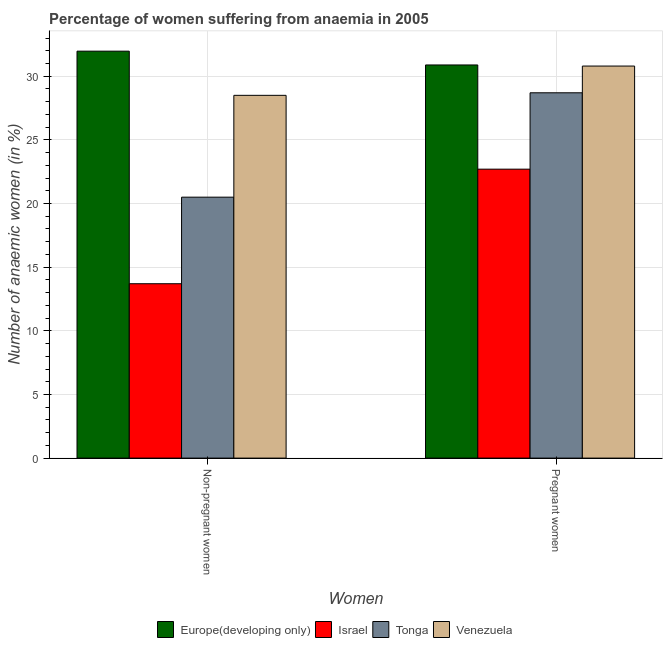How many different coloured bars are there?
Give a very brief answer. 4. How many bars are there on the 2nd tick from the left?
Your response must be concise. 4. What is the label of the 1st group of bars from the left?
Offer a very short reply. Non-pregnant women. What is the percentage of pregnant anaemic women in Venezuela?
Offer a very short reply. 30.8. Across all countries, what is the maximum percentage of pregnant anaemic women?
Give a very brief answer. 30.89. In which country was the percentage of pregnant anaemic women maximum?
Your answer should be compact. Europe(developing only). What is the total percentage of pregnant anaemic women in the graph?
Your answer should be very brief. 113.09. What is the difference between the percentage of non-pregnant anaemic women in Tonga and that in Venezuela?
Make the answer very short. -8. What is the difference between the percentage of pregnant anaemic women in Europe(developing only) and the percentage of non-pregnant anaemic women in Israel?
Your answer should be compact. 17.19. What is the average percentage of non-pregnant anaemic women per country?
Your answer should be compact. 23.67. What is the difference between the percentage of pregnant anaemic women and percentage of non-pregnant anaemic women in Europe(developing only)?
Give a very brief answer. -1.08. In how many countries, is the percentage of pregnant anaemic women greater than 26 %?
Keep it short and to the point. 3. What is the ratio of the percentage of non-pregnant anaemic women in Israel to that in Tonga?
Provide a succinct answer. 0.67. What does the 1st bar from the left in Pregnant women represents?
Provide a short and direct response. Europe(developing only). What does the 2nd bar from the right in Non-pregnant women represents?
Ensure brevity in your answer.  Tonga. How many countries are there in the graph?
Offer a very short reply. 4. What is the difference between two consecutive major ticks on the Y-axis?
Give a very brief answer. 5. Does the graph contain grids?
Provide a short and direct response. Yes. How many legend labels are there?
Make the answer very short. 4. What is the title of the graph?
Your response must be concise. Percentage of women suffering from anaemia in 2005. What is the label or title of the X-axis?
Ensure brevity in your answer.  Women. What is the label or title of the Y-axis?
Keep it short and to the point. Number of anaemic women (in %). What is the Number of anaemic women (in %) in Europe(developing only) in Non-pregnant women?
Offer a very short reply. 31.97. What is the Number of anaemic women (in %) in Israel in Non-pregnant women?
Give a very brief answer. 13.7. What is the Number of anaemic women (in %) of Venezuela in Non-pregnant women?
Your answer should be compact. 28.5. What is the Number of anaemic women (in %) of Europe(developing only) in Pregnant women?
Ensure brevity in your answer.  30.89. What is the Number of anaemic women (in %) of Israel in Pregnant women?
Give a very brief answer. 22.7. What is the Number of anaemic women (in %) in Tonga in Pregnant women?
Your answer should be compact. 28.7. What is the Number of anaemic women (in %) of Venezuela in Pregnant women?
Your answer should be compact. 30.8. Across all Women, what is the maximum Number of anaemic women (in %) in Europe(developing only)?
Your answer should be very brief. 31.97. Across all Women, what is the maximum Number of anaemic women (in %) of Israel?
Offer a very short reply. 22.7. Across all Women, what is the maximum Number of anaemic women (in %) in Tonga?
Give a very brief answer. 28.7. Across all Women, what is the maximum Number of anaemic women (in %) in Venezuela?
Provide a succinct answer. 30.8. Across all Women, what is the minimum Number of anaemic women (in %) in Europe(developing only)?
Your answer should be very brief. 30.89. Across all Women, what is the minimum Number of anaemic women (in %) in Israel?
Ensure brevity in your answer.  13.7. What is the total Number of anaemic women (in %) in Europe(developing only) in the graph?
Provide a succinct answer. 62.86. What is the total Number of anaemic women (in %) of Israel in the graph?
Provide a succinct answer. 36.4. What is the total Number of anaemic women (in %) in Tonga in the graph?
Make the answer very short. 49.2. What is the total Number of anaemic women (in %) of Venezuela in the graph?
Make the answer very short. 59.3. What is the difference between the Number of anaemic women (in %) of Europe(developing only) in Non-pregnant women and that in Pregnant women?
Offer a terse response. 1.08. What is the difference between the Number of anaemic women (in %) in Tonga in Non-pregnant women and that in Pregnant women?
Keep it short and to the point. -8.2. What is the difference between the Number of anaemic women (in %) in Europe(developing only) in Non-pregnant women and the Number of anaemic women (in %) in Israel in Pregnant women?
Ensure brevity in your answer.  9.27. What is the difference between the Number of anaemic women (in %) of Europe(developing only) in Non-pregnant women and the Number of anaemic women (in %) of Tonga in Pregnant women?
Your answer should be very brief. 3.27. What is the difference between the Number of anaemic women (in %) of Europe(developing only) in Non-pregnant women and the Number of anaemic women (in %) of Venezuela in Pregnant women?
Offer a terse response. 1.17. What is the difference between the Number of anaemic women (in %) of Israel in Non-pregnant women and the Number of anaemic women (in %) of Venezuela in Pregnant women?
Provide a succinct answer. -17.1. What is the difference between the Number of anaemic women (in %) of Tonga in Non-pregnant women and the Number of anaemic women (in %) of Venezuela in Pregnant women?
Offer a very short reply. -10.3. What is the average Number of anaemic women (in %) of Europe(developing only) per Women?
Make the answer very short. 31.43. What is the average Number of anaemic women (in %) in Israel per Women?
Ensure brevity in your answer.  18.2. What is the average Number of anaemic women (in %) of Tonga per Women?
Your answer should be very brief. 24.6. What is the average Number of anaemic women (in %) of Venezuela per Women?
Keep it short and to the point. 29.65. What is the difference between the Number of anaemic women (in %) of Europe(developing only) and Number of anaemic women (in %) of Israel in Non-pregnant women?
Ensure brevity in your answer.  18.27. What is the difference between the Number of anaemic women (in %) in Europe(developing only) and Number of anaemic women (in %) in Tonga in Non-pregnant women?
Provide a succinct answer. 11.47. What is the difference between the Number of anaemic women (in %) of Europe(developing only) and Number of anaemic women (in %) of Venezuela in Non-pregnant women?
Your response must be concise. 3.47. What is the difference between the Number of anaemic women (in %) of Israel and Number of anaemic women (in %) of Tonga in Non-pregnant women?
Ensure brevity in your answer.  -6.8. What is the difference between the Number of anaemic women (in %) in Israel and Number of anaemic women (in %) in Venezuela in Non-pregnant women?
Offer a very short reply. -14.8. What is the difference between the Number of anaemic women (in %) of Europe(developing only) and Number of anaemic women (in %) of Israel in Pregnant women?
Provide a succinct answer. 8.19. What is the difference between the Number of anaemic women (in %) in Europe(developing only) and Number of anaemic women (in %) in Tonga in Pregnant women?
Offer a very short reply. 2.19. What is the difference between the Number of anaemic women (in %) of Europe(developing only) and Number of anaemic women (in %) of Venezuela in Pregnant women?
Keep it short and to the point. 0.09. What is the difference between the Number of anaemic women (in %) of Israel and Number of anaemic women (in %) of Tonga in Pregnant women?
Keep it short and to the point. -6. What is the ratio of the Number of anaemic women (in %) of Europe(developing only) in Non-pregnant women to that in Pregnant women?
Your answer should be compact. 1.04. What is the ratio of the Number of anaemic women (in %) of Israel in Non-pregnant women to that in Pregnant women?
Provide a short and direct response. 0.6. What is the ratio of the Number of anaemic women (in %) of Venezuela in Non-pregnant women to that in Pregnant women?
Your answer should be compact. 0.93. What is the difference between the highest and the second highest Number of anaemic women (in %) in Europe(developing only)?
Your answer should be very brief. 1.08. What is the difference between the highest and the lowest Number of anaemic women (in %) in Europe(developing only)?
Make the answer very short. 1.08. What is the difference between the highest and the lowest Number of anaemic women (in %) in Israel?
Ensure brevity in your answer.  9. What is the difference between the highest and the lowest Number of anaemic women (in %) in Tonga?
Provide a short and direct response. 8.2. 